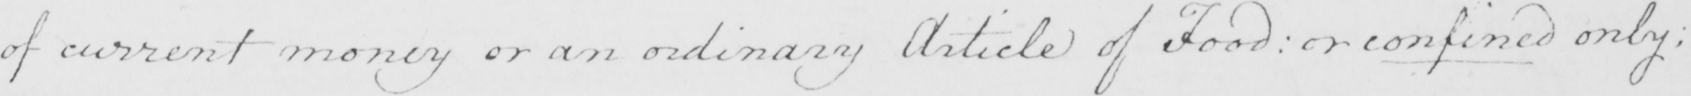What is written in this line of handwriting? of current money or an ordinary Article of food  :  or confined only : 